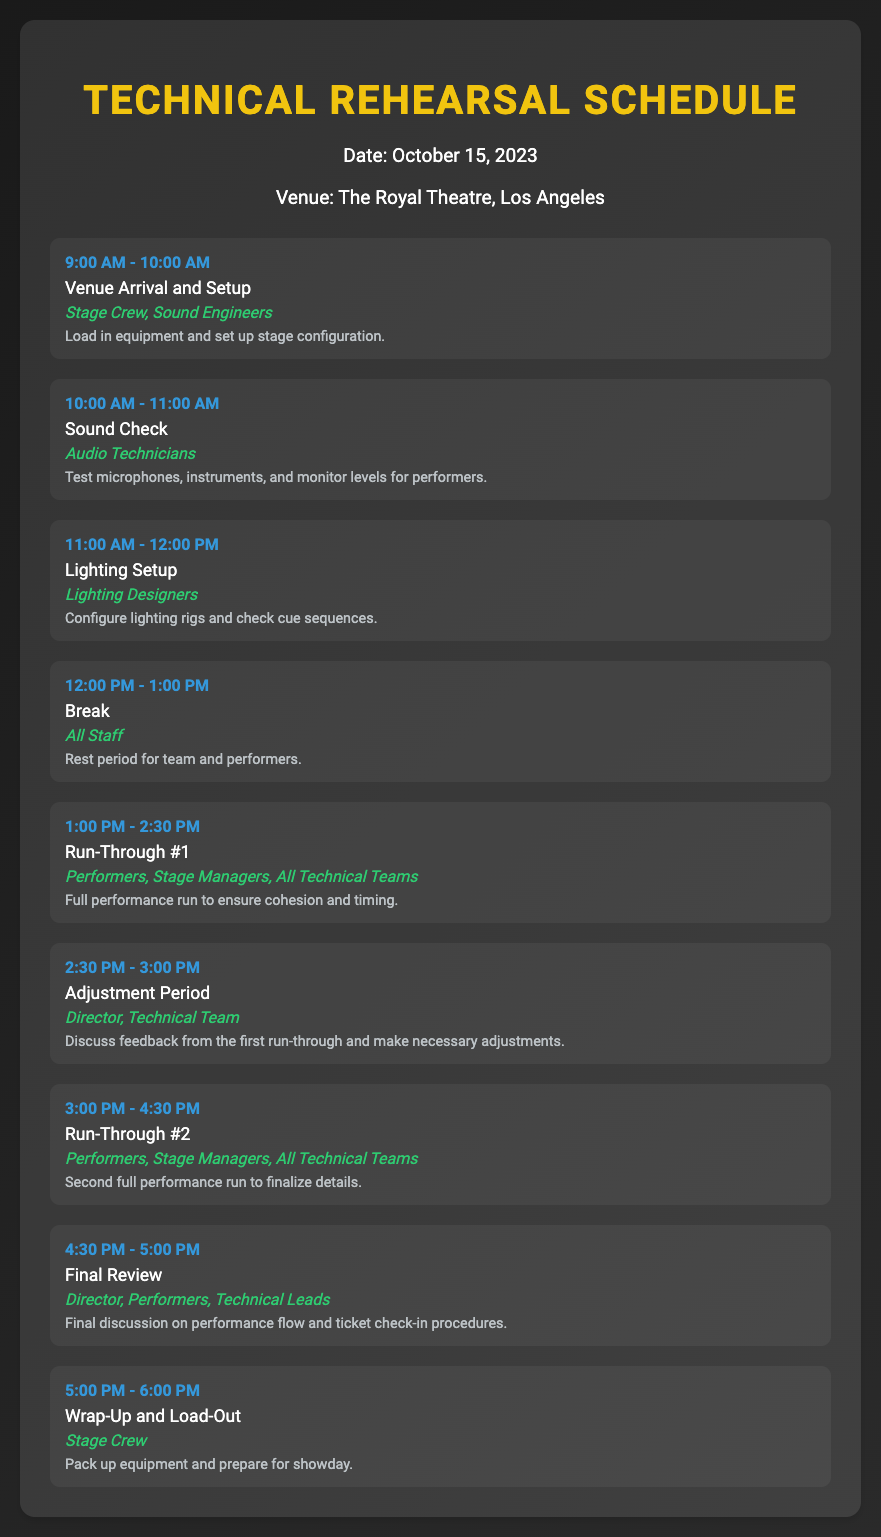What time is the first sound check scheduled? The first sound check is listed under "Sound Check" from 10:00 AM to 11:00 AM.
Answer: 10:00 AM - 11:00 AM Who is responsible for the lighting setup? The lighting setup is managed by "Lighting Designers", as indicated in the schedule.
Answer: Lighting Designers What activity follows the first run-through? After the first run-through, there is an "Adjustment Period" scheduled.
Answer: Adjustment Period How long is the break scheduled for all staff? The break is scheduled from 12:00 PM to 1:00 PM.
Answer: 1 hour Which team has the final review meeting? The final review involves the "Director, Performers, Technical Leads".
Answer: Director, Performers, Technical Leads What is the last activity before load-out? The last activity before load-out is "Wrap-Up and Load-Out".
Answer: Wrap-Up and Load-Out When does the run-through #2 take place? Run-through #2 occurs after the adjustment period, specifically from 3:00 PM to 4:30 PM.
Answer: 3:00 PM - 4:30 PM What is noted about the venue arrival? During the venue arrival, equipment is loaded in and stage configuration is set up.
Answer: Load in equipment and set up stage configuration 